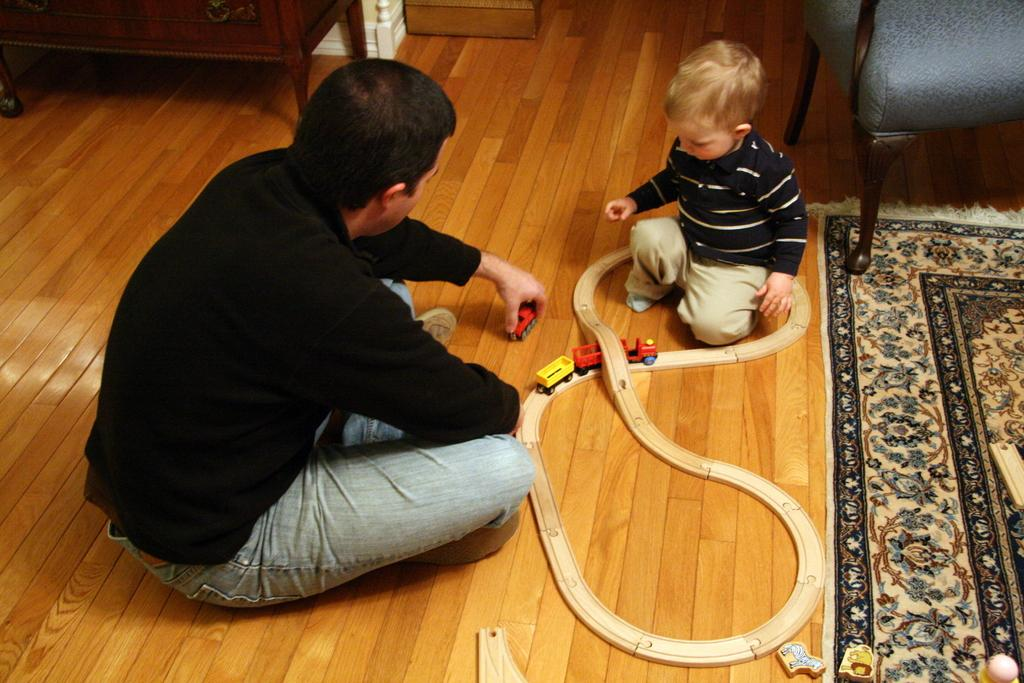Who is present in the image? There is a man and a boy in the image. What are the man and the boy doing in the image? Both the man and the boy are sitting on the floor. What objects can be seen in the image? There are toys and a carpet in the image. Are there any furniture items visible in the image? Yes, there is a chair in the image. What can be seen in the background of the image? There is a table visible in the background of the image. How many pigs are visible in the image? There are no pigs present in the image. What type of debt is being discussed by the man and the boy in the image? There is no discussion of debt in the image; it features a man and a boy sitting on the floor with toys and a carpet. 